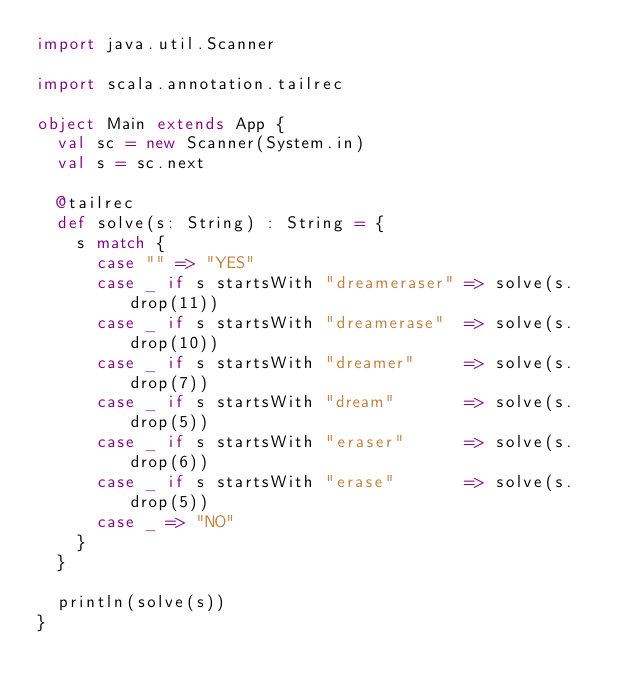Convert code to text. <code><loc_0><loc_0><loc_500><loc_500><_Scala_>import java.util.Scanner

import scala.annotation.tailrec

object Main extends App {
  val sc = new Scanner(System.in)
  val s = sc.next

  @tailrec
  def solve(s: String) : String = {
    s match {
      case "" => "YES"
      case _ if s startsWith "dreameraser" => solve(s.drop(11))
      case _ if s startsWith "dreamerase"  => solve(s.drop(10))
      case _ if s startsWith "dreamer"     => solve(s.drop(7))
      case _ if s startsWith "dream"       => solve(s.drop(5))
      case _ if s startsWith "eraser"      => solve(s.drop(6))
      case _ if s startsWith "erase"       => solve(s.drop(5))
      case _ => "NO"
    }
  }

  println(solve(s))
}
</code> 